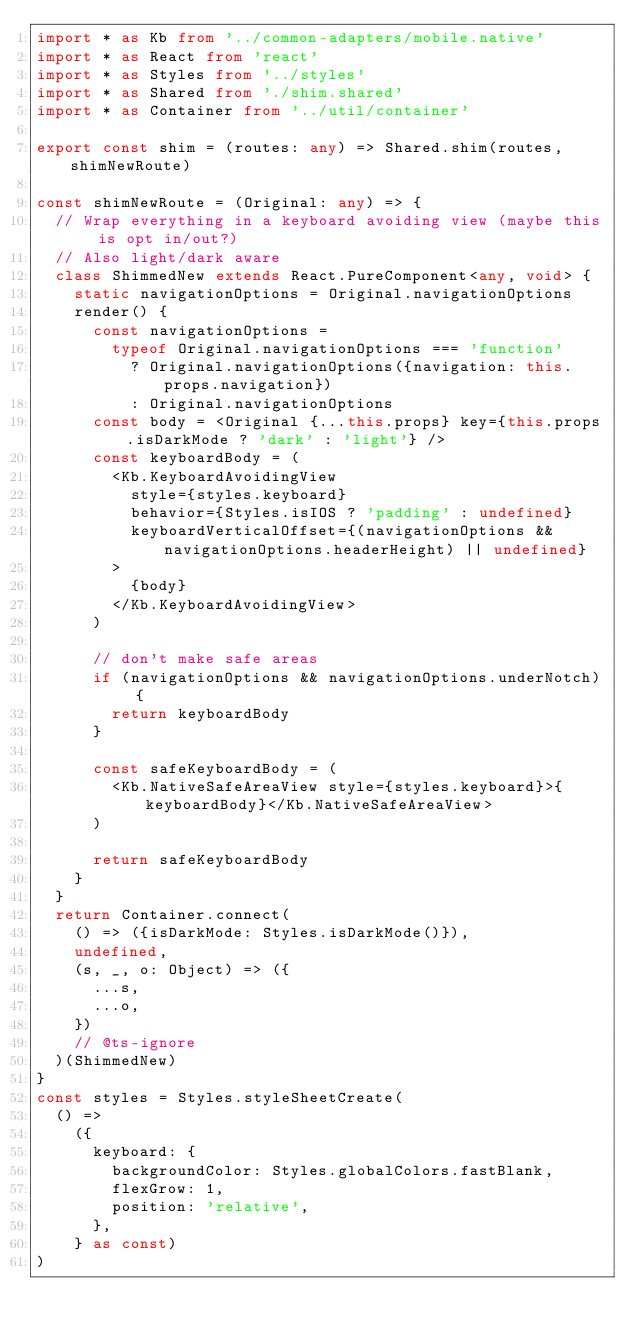Convert code to text. <code><loc_0><loc_0><loc_500><loc_500><_TypeScript_>import * as Kb from '../common-adapters/mobile.native'
import * as React from 'react'
import * as Styles from '../styles'
import * as Shared from './shim.shared'
import * as Container from '../util/container'

export const shim = (routes: any) => Shared.shim(routes, shimNewRoute)

const shimNewRoute = (Original: any) => {
  // Wrap everything in a keyboard avoiding view (maybe this is opt in/out?)
  // Also light/dark aware
  class ShimmedNew extends React.PureComponent<any, void> {
    static navigationOptions = Original.navigationOptions
    render() {
      const navigationOptions =
        typeof Original.navigationOptions === 'function'
          ? Original.navigationOptions({navigation: this.props.navigation})
          : Original.navigationOptions
      const body = <Original {...this.props} key={this.props.isDarkMode ? 'dark' : 'light'} />
      const keyboardBody = (
        <Kb.KeyboardAvoidingView
          style={styles.keyboard}
          behavior={Styles.isIOS ? 'padding' : undefined}
          keyboardVerticalOffset={(navigationOptions && navigationOptions.headerHeight) || undefined}
        >
          {body}
        </Kb.KeyboardAvoidingView>
      )

      // don't make safe areas
      if (navigationOptions && navigationOptions.underNotch) {
        return keyboardBody
      }

      const safeKeyboardBody = (
        <Kb.NativeSafeAreaView style={styles.keyboard}>{keyboardBody}</Kb.NativeSafeAreaView>
      )

      return safeKeyboardBody
    }
  }
  return Container.connect(
    () => ({isDarkMode: Styles.isDarkMode()}),
    undefined,
    (s, _, o: Object) => ({
      ...s,
      ...o,
    })
    // @ts-ignore
  )(ShimmedNew)
}
const styles = Styles.styleSheetCreate(
  () =>
    ({
      keyboard: {
        backgroundColor: Styles.globalColors.fastBlank,
        flexGrow: 1,
        position: 'relative',
      },
    } as const)
)
</code> 